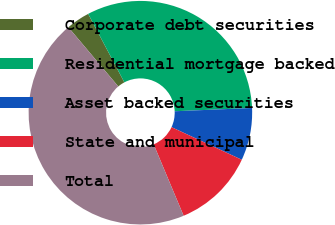Convert chart. <chart><loc_0><loc_0><loc_500><loc_500><pie_chart><fcel>Corporate debt securities<fcel>Residential mortgage backed<fcel>Asset backed securities<fcel>State and municipal<fcel>Total<nl><fcel>3.41%<fcel>32.06%<fcel>7.59%<fcel>11.76%<fcel>45.17%<nl></chart> 